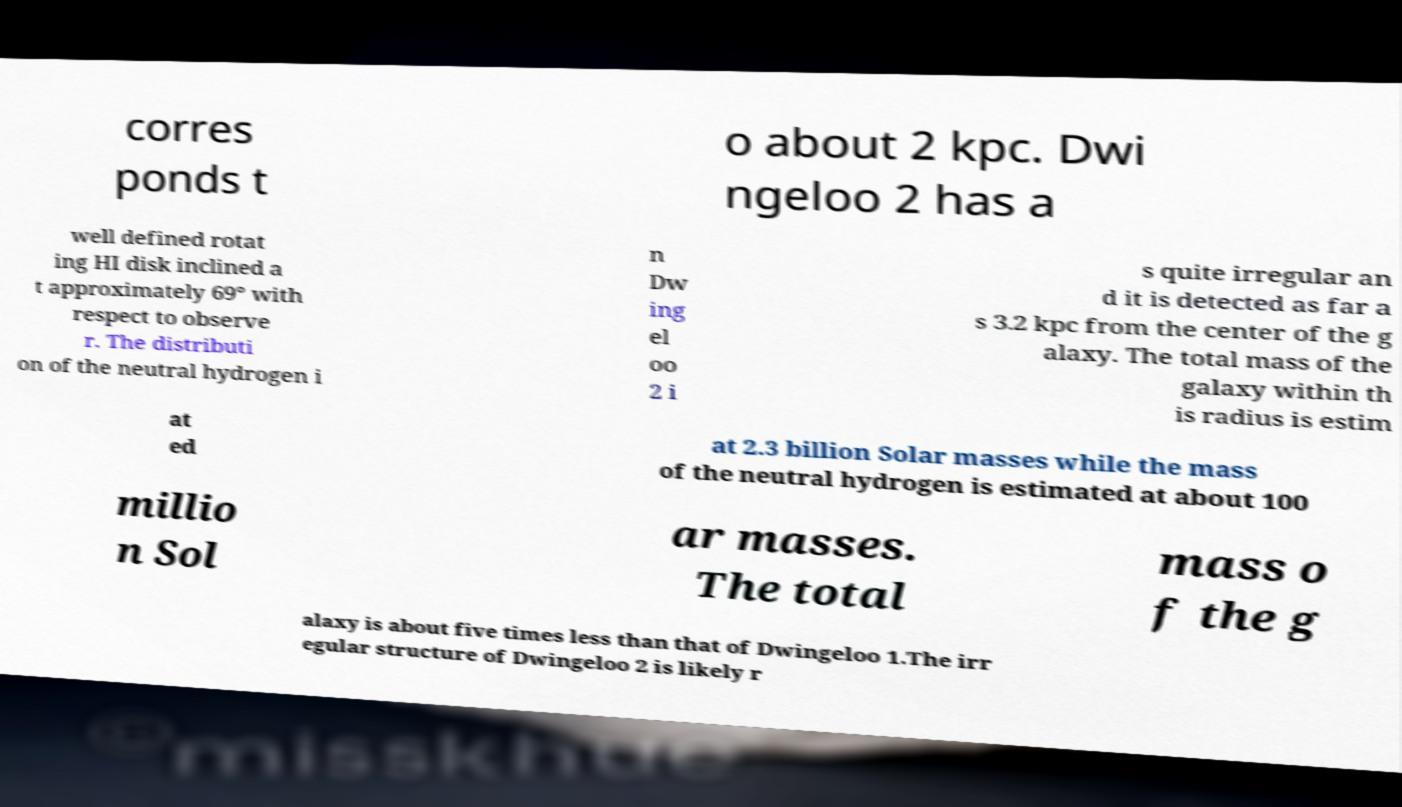I need the written content from this picture converted into text. Can you do that? corres ponds t o about 2 kpc. Dwi ngeloo 2 has a well defined rotat ing HI disk inclined a t approximately 69° with respect to observe r. The distributi on of the neutral hydrogen i n Dw ing el oo 2 i s quite irregular an d it is detected as far a s 3.2 kpc from the center of the g alaxy. The total mass of the galaxy within th is radius is estim at ed at 2.3 billion Solar masses while the mass of the neutral hydrogen is estimated at about 100 millio n Sol ar masses. The total mass o f the g alaxy is about five times less than that of Dwingeloo 1.The irr egular structure of Dwingeloo 2 is likely r 